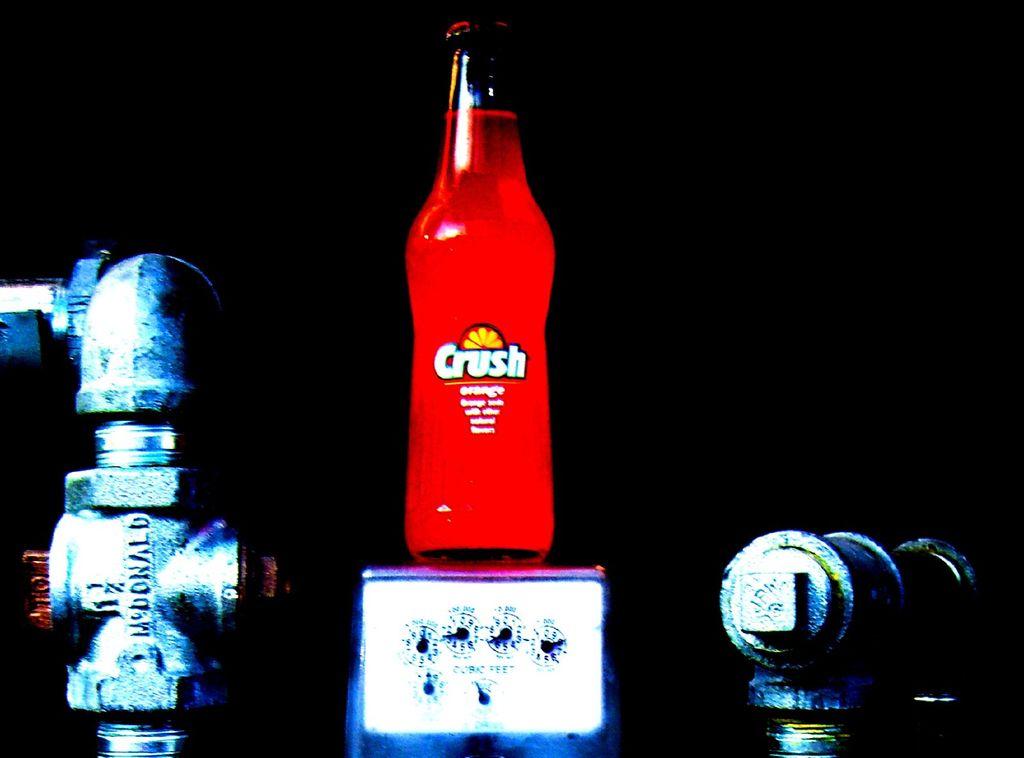What is the name of this drink?
Your response must be concise. Crush. 